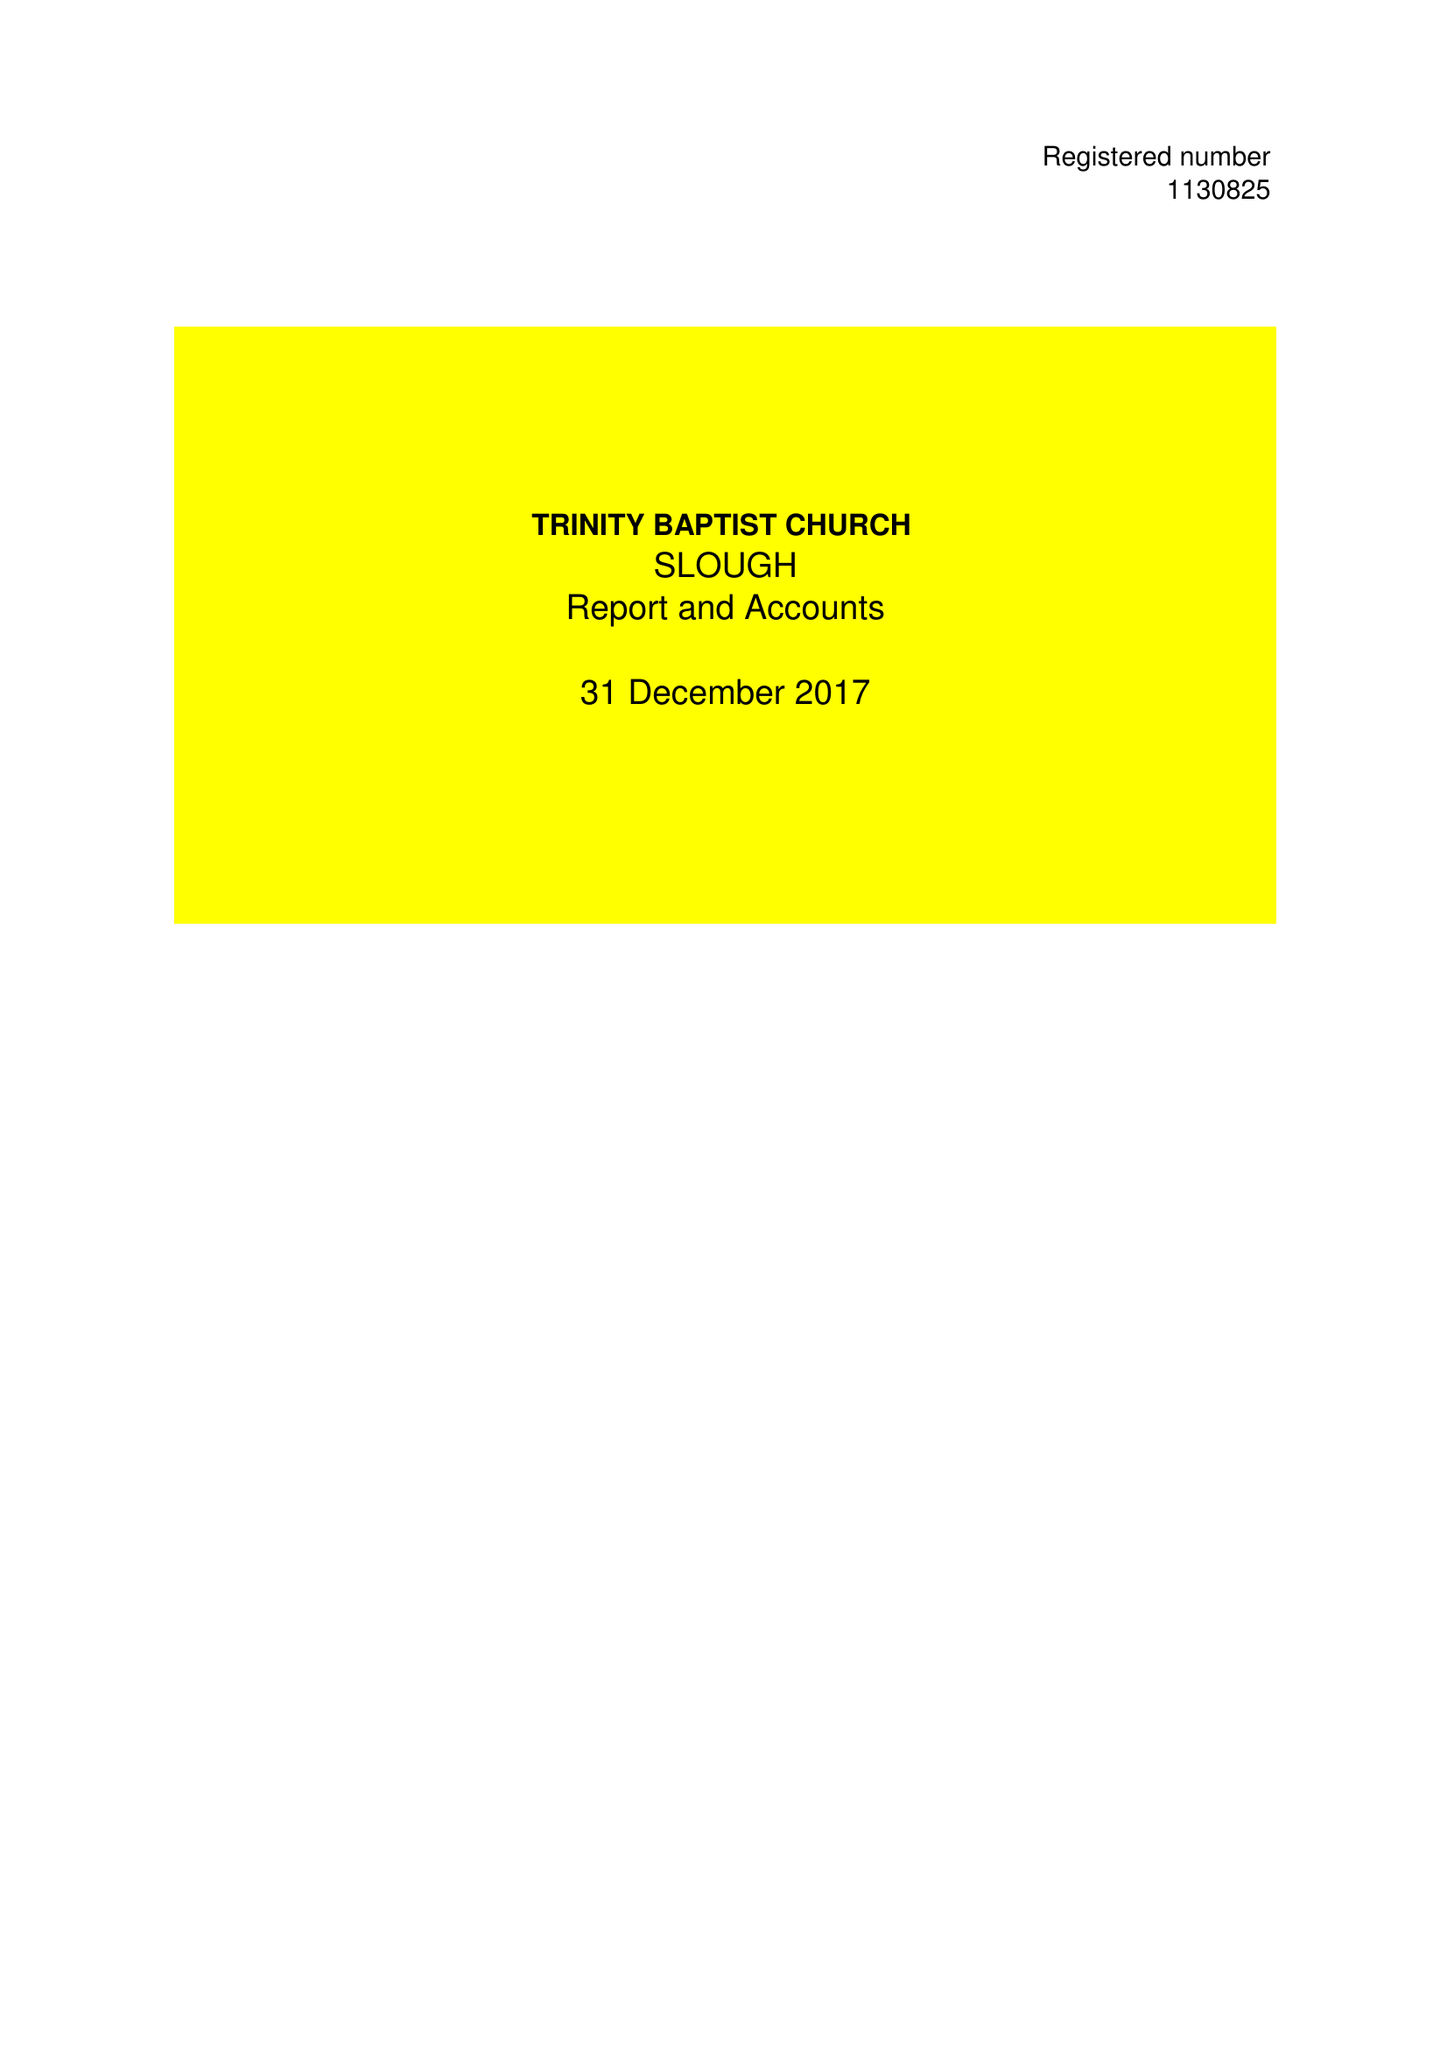What is the value for the address__post_town?
Answer the question using a single word or phrase. MITCHAM 